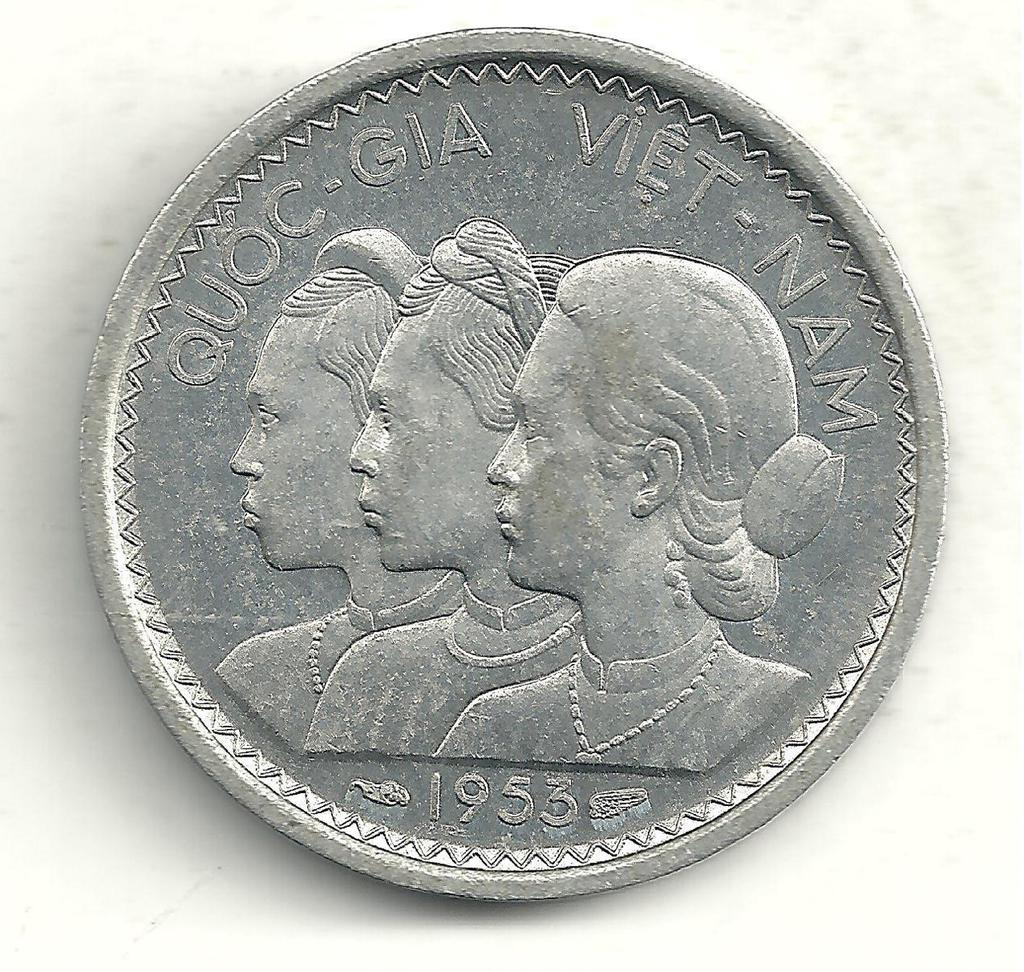<image>
Relay a brief, clear account of the picture shown. a silver coin with three heads and the date 1953 at the bottom 